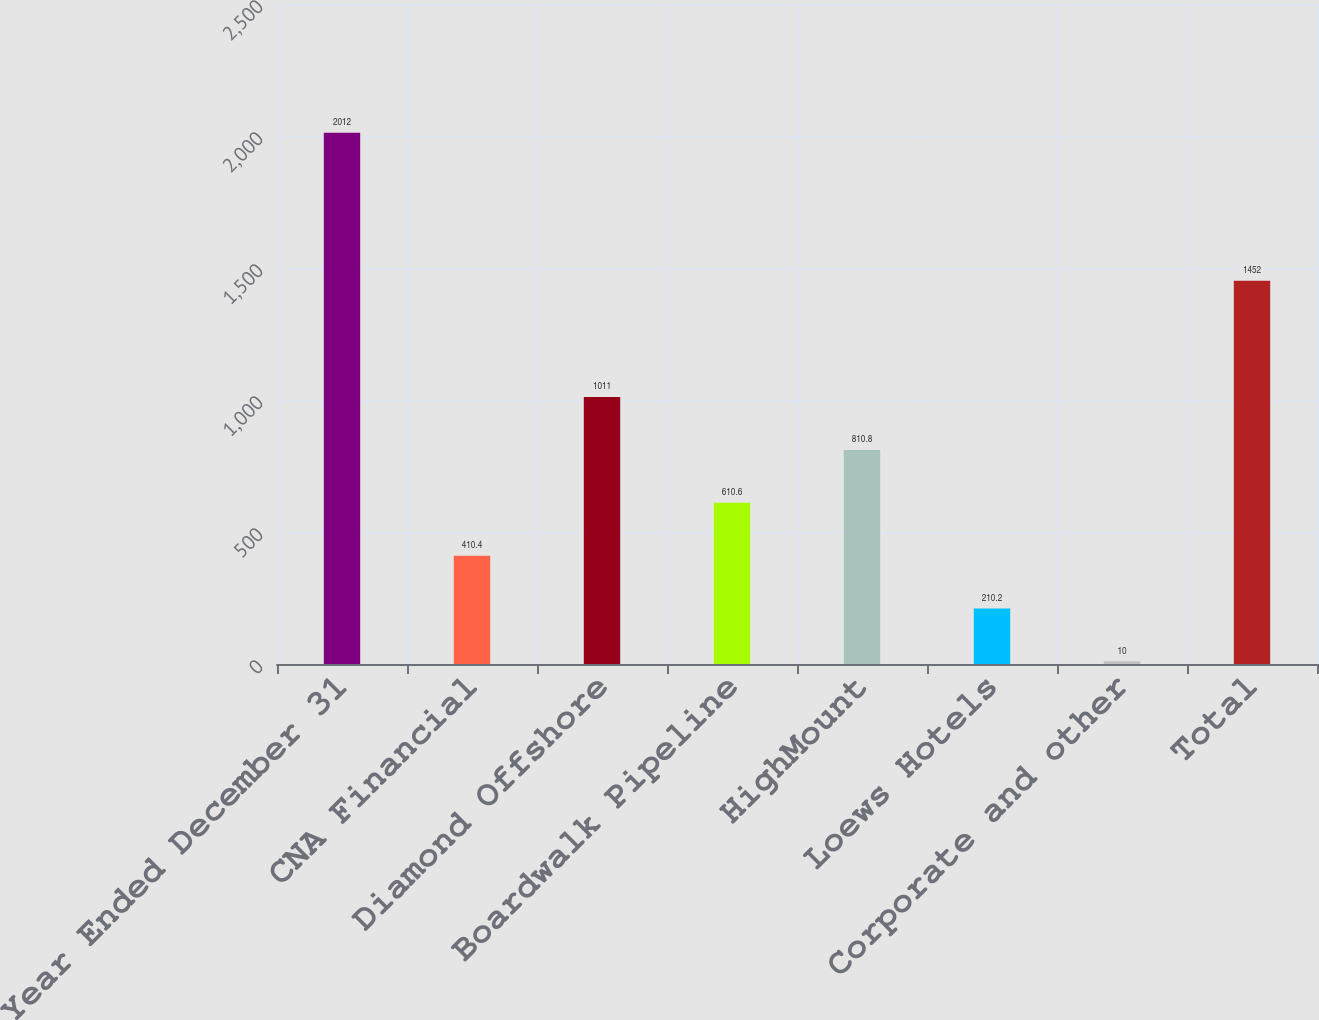<chart> <loc_0><loc_0><loc_500><loc_500><bar_chart><fcel>Year Ended December 31<fcel>CNA Financial<fcel>Diamond Offshore<fcel>Boardwalk Pipeline<fcel>HighMount<fcel>Loews Hotels<fcel>Corporate and other<fcel>Total<nl><fcel>2012<fcel>410.4<fcel>1011<fcel>610.6<fcel>810.8<fcel>210.2<fcel>10<fcel>1452<nl></chart> 